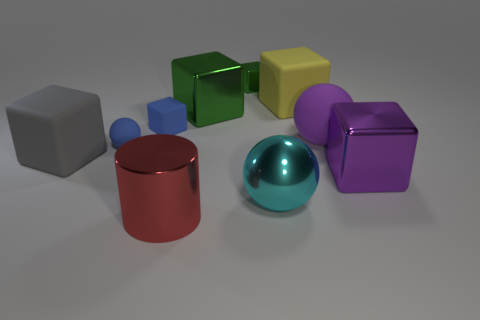What can you tell me about the lighting and shadows in the scene? The lighting in the scene appears to be diffused, possibly from an overhead source, creating soft shadows to the right of the objects. This indicates the light source is coming from the top left, and the shadows provide a sense of depth and dimensionality to the objects. 